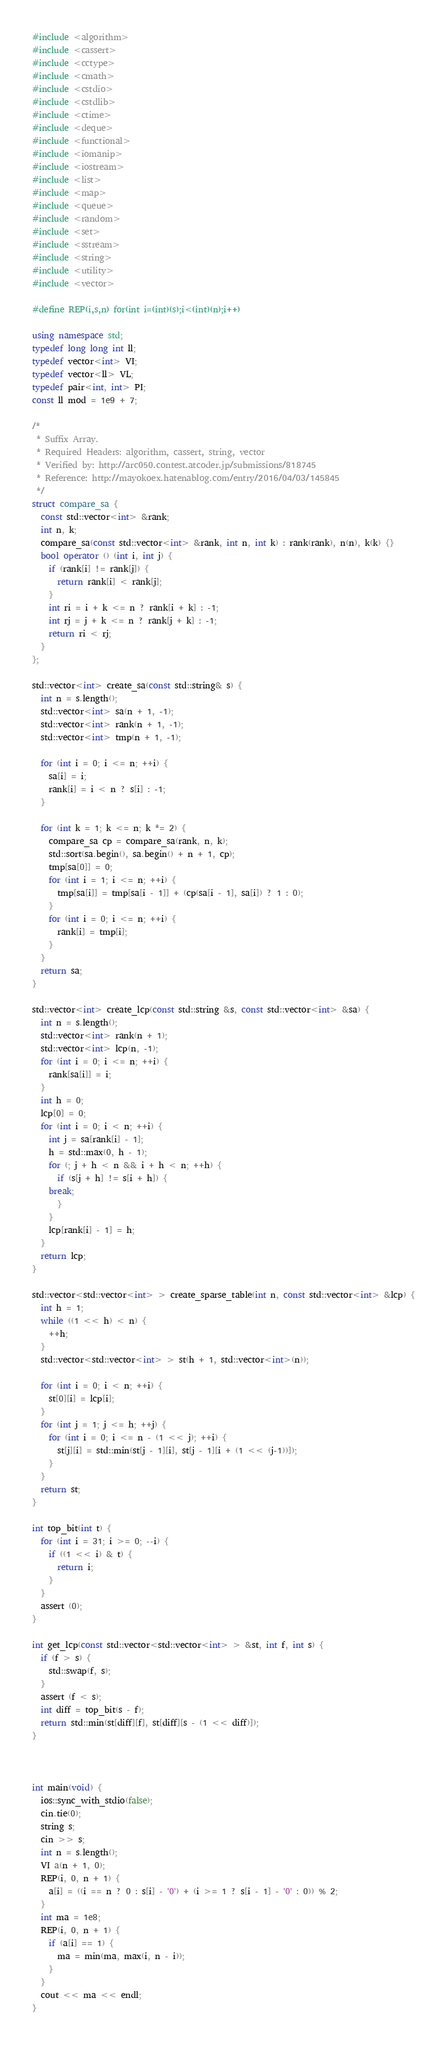<code> <loc_0><loc_0><loc_500><loc_500><_C++_>#include <algorithm>
#include <cassert>
#include <cctype>
#include <cmath>
#include <cstdio>
#include <cstdlib>
#include <ctime>
#include <deque>
#include <functional>
#include <iomanip>
#include <iostream>
#include <list>
#include <map>
#include <queue>
#include <random>
#include <set>
#include <sstream>
#include <string>
#include <utility>
#include <vector>

#define REP(i,s,n) for(int i=(int)(s);i<(int)(n);i++)

using namespace std;
typedef long long int ll;
typedef vector<int> VI;
typedef vector<ll> VL;
typedef pair<int, int> PI;
const ll mod = 1e9 + 7;

/*
 * Suffix Array.
 * Required Headers: algorithm, cassert, string, vector
 * Verified by: http://arc050.contest.atcoder.jp/submissions/818745
 * Reference: http://mayokoex.hatenablog.com/entry/2016/04/03/145845
 */
struct compare_sa {
  const std::vector<int> &rank;
  int n, k;
  compare_sa(const std::vector<int> &rank, int n, int k) : rank(rank), n(n), k(k) {}
  bool operator () (int i, int j) {
    if (rank[i] != rank[j]) {
      return rank[i] < rank[j];
    }
    int ri = i + k <= n ? rank[i + k] : -1;
    int rj = j + k <= n ? rank[j + k] : -1;
    return ri < rj;
  }
};

std::vector<int> create_sa(const std::string& s) {
  int n = s.length();
  std::vector<int> sa(n + 1, -1);
  std::vector<int> rank(n + 1, -1);
  std::vector<int> tmp(n + 1, -1);
  
  for (int i = 0; i <= n; ++i) {
    sa[i] = i;
    rank[i] = i < n ? s[i] : -1;
  }
  
  for (int k = 1; k <= n; k *= 2) {
    compare_sa cp = compare_sa(rank, n, k);
    std::sort(sa.begin(), sa.begin() + n + 1, cp);
    tmp[sa[0]] = 0;
    for (int i = 1; i <= n; ++i) {
      tmp[sa[i]] = tmp[sa[i - 1]] + (cp(sa[i - 1], sa[i]) ? 1 : 0);
    }
    for (int i = 0; i <= n; ++i) {
      rank[i] = tmp[i];
    }
  }
  return sa;
}

std::vector<int> create_lcp(const std::string &s, const std::vector<int> &sa) {
  int n = s.length();
  std::vector<int> rank(n + 1);
  std::vector<int> lcp(n, -1);
  for (int i = 0; i <= n; ++i) {
    rank[sa[i]] = i;
  }
  int h = 0;
  lcp[0] = 0;
  for (int i = 0; i < n; ++i) {
    int j = sa[rank[i] - 1];
    h = std::max(0, h - 1);
    for (; j + h < n && i + h < n; ++h) {
      if (s[j + h] != s[i + h]) {
	break;
      }
    }
    lcp[rank[i] - 1] = h;
  }
  return lcp;
}

std::vector<std::vector<int> > create_sparse_table(int n, const std::vector<int> &lcp) {
  int h = 1;
  while ((1 << h) < n) {
    ++h;
  }
  std::vector<std::vector<int> > st(h + 1, std::vector<int>(n));

  for (int i = 0; i < n; ++i) {
    st[0][i] = lcp[i];
  }
  for (int j = 1; j <= h; ++j) {
    for (int i = 0; i <= n - (1 << j); ++i) {
      st[j][i] = std::min(st[j - 1][i], st[j - 1][i + (1 << (j-1))]);
    }
  }
  return st;
}

int top_bit(int t) {
  for (int i = 31; i >= 0; --i) {
    if ((1 << i) & t) {
      return i;
    }
  }
  assert (0);
}

int get_lcp(const std::vector<std::vector<int> > &st, int f, int s) {
  if (f > s) {
    std::swap(f, s);
  }
  assert (f < s);
  int diff = top_bit(s - f);
  return std::min(st[diff][f], st[diff][s - (1 << diff)]);
}



int main(void) {
  ios::sync_with_stdio(false);
  cin.tie(0);
  string s;
  cin >> s;
  int n = s.length();
  VI a(n + 1, 0);
  REP(i, 0, n + 1) {
    a[i] = ((i == n ? 0 : s[i] - '0') + (i >= 1 ? s[i - 1] - '0' : 0)) % 2;
  }
  int ma = 1e8;
  REP(i, 0, n + 1) {
    if (a[i] == 1) {
      ma = min(ma, max(i, n - i));
    }
  }
  cout << ma << endl;
}
</code> 